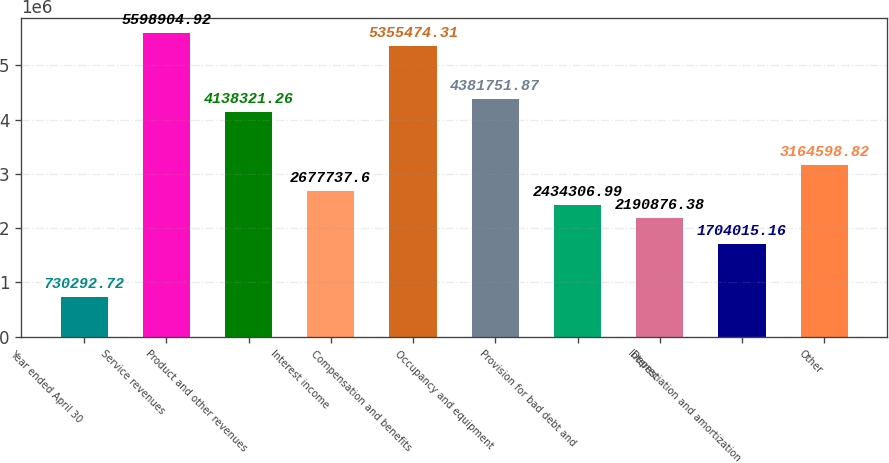<chart> <loc_0><loc_0><loc_500><loc_500><bar_chart><fcel>Year ended April 30<fcel>Service revenues<fcel>Product and other revenues<fcel>Interest income<fcel>Compensation and benefits<fcel>Occupancy and equipment<fcel>Provision for bad debt and<fcel>Interest<fcel>Depreciation and amortization<fcel>Other<nl><fcel>730293<fcel>5.5989e+06<fcel>4.13832e+06<fcel>2.67774e+06<fcel>5.35547e+06<fcel>4.38175e+06<fcel>2.43431e+06<fcel>2.19088e+06<fcel>1.70402e+06<fcel>3.1646e+06<nl></chart> 